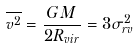<formula> <loc_0><loc_0><loc_500><loc_500>\overline { v ^ { 2 } } = \frac { G M } { 2 R _ { v i r } } = 3 \sigma ^ { 2 } _ { r v }</formula> 